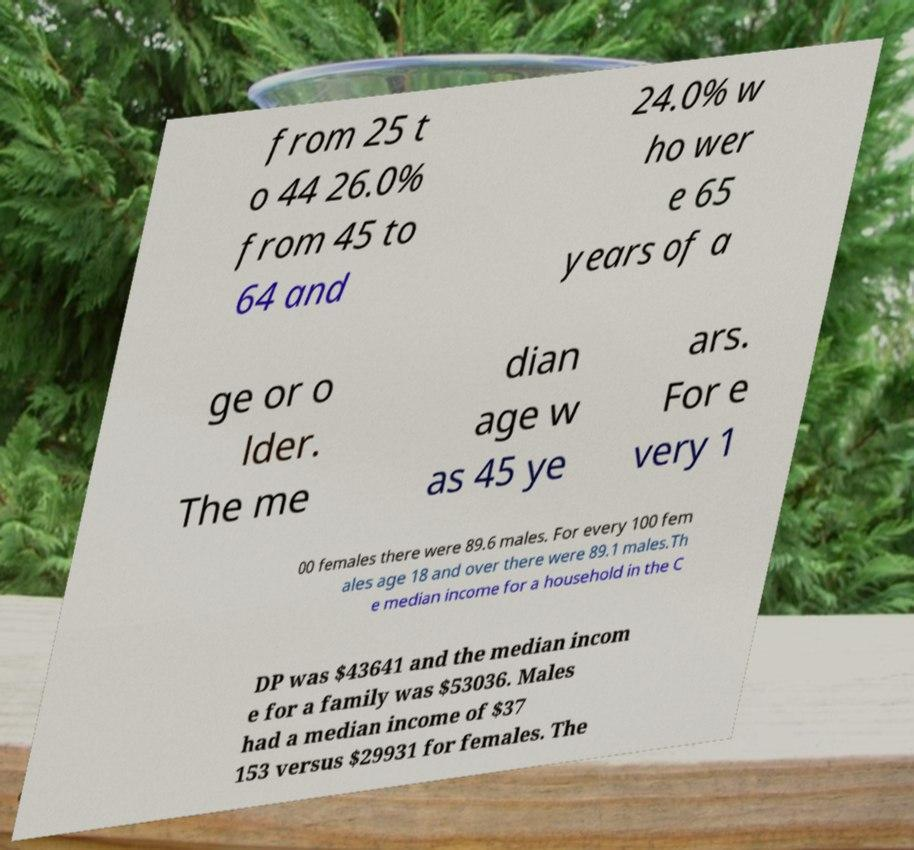Please read and relay the text visible in this image. What does it say? from 25 t o 44 26.0% from 45 to 64 and 24.0% w ho wer e 65 years of a ge or o lder. The me dian age w as 45 ye ars. For e very 1 00 females there were 89.6 males. For every 100 fem ales age 18 and over there were 89.1 males.Th e median income for a household in the C DP was $43641 and the median incom e for a family was $53036. Males had a median income of $37 153 versus $29931 for females. The 